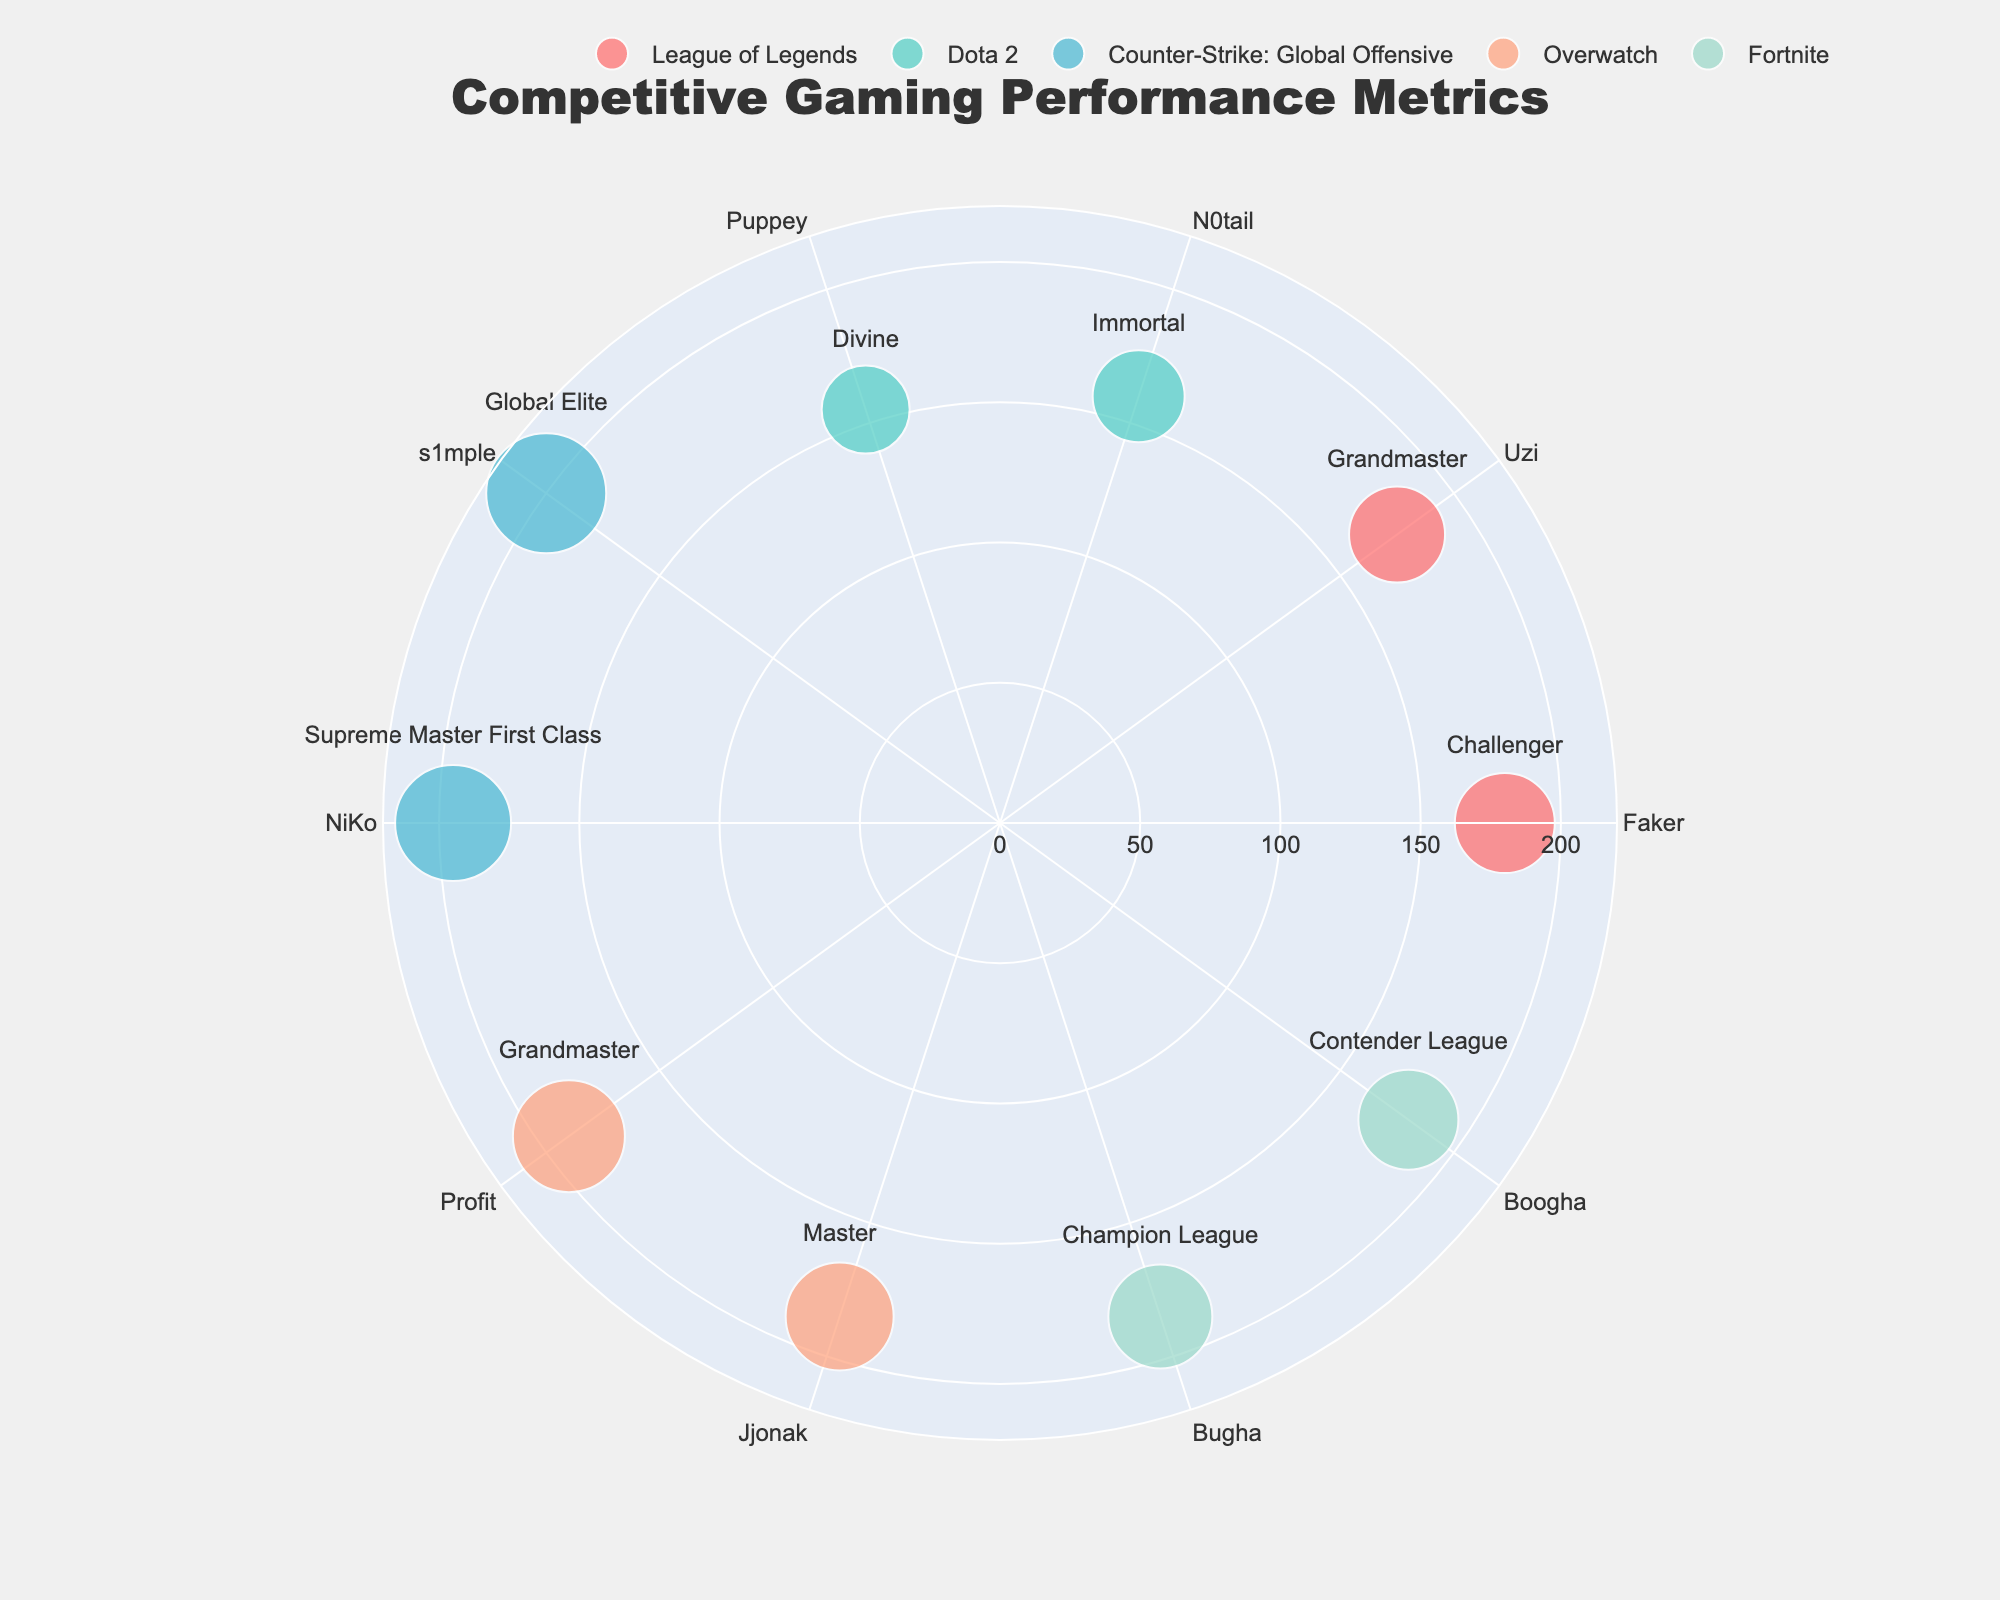What is the title of the figure? The title is usually found at the top center of the figure and provides a concise summary of what the chart represents.
Answer: Competitive Gaming Performance Metrics How many data points are there for Counter-Strike: Global Offensive? Look for the color that represents Counter-Strike: Global Offensive; count the number of markers along the theta axis for that color.
Answer: 2 Which player has the highest number of wins in Overwatch? Identify the color representing Overwatch, then find the marker with the greatest radial value.
Answer: Profit What is the difference in matches played between s1mple and NiKo? Count the number of matches played for each player and then subtract the matches played by NiKo from those played by s1mple.
Answer: 10 Which game has the most evenly distributed number of wins among its players? Compare the radial distances of markers for each game to see which has the least variation among its data points.
Answer: Fortnite Who has the better win-loss ratio, Faker or Uzi? Calculate the win-loss ratio for both players by dividing wins by losses and compare the results.
Answer: Faker Rank the players in League of Legends by their rank (from highest to lowest). Reference the text labels next to markers for League of Legends and arrange them from highest to lowest (Challenger, Grandmaster, etc.).
Answer: Faker, Uzi Which game title shows the largest size difference in markers? Compare the marker sizes (which represent matches played) across all game titles to identify the game with the most significant size variation.
Answer: Counter-Strike: Global Offensive What is the median number of wins for all players in the figure? List the number of wins for each player, sort them in ascending order, and find the middle number.
Answer: 185 